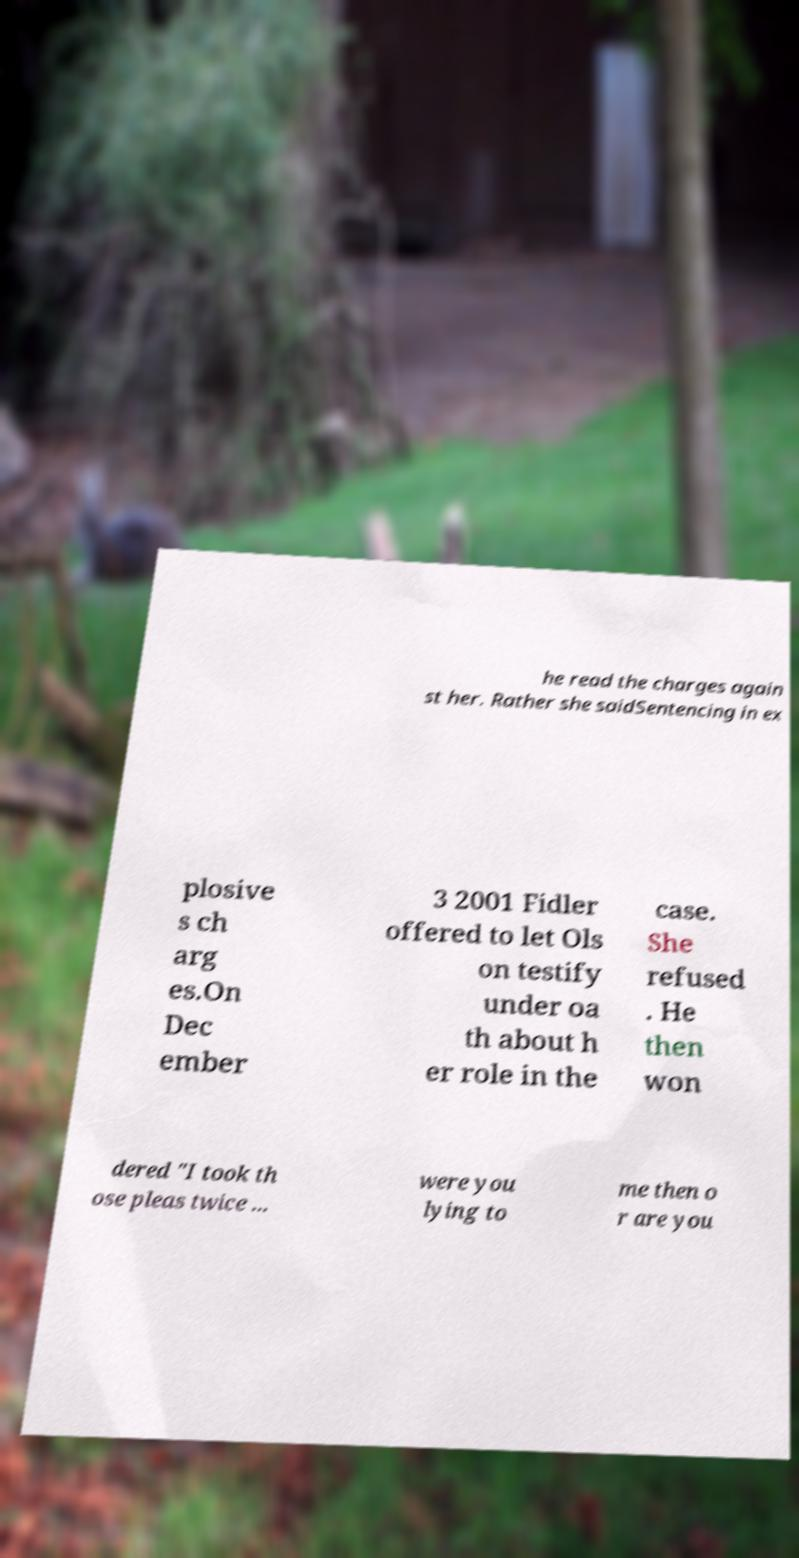For documentation purposes, I need the text within this image transcribed. Could you provide that? he read the charges again st her. Rather she saidSentencing in ex plosive s ch arg es.On Dec ember 3 2001 Fidler offered to let Ols on testify under oa th about h er role in the case. She refused . He then won dered "I took th ose pleas twice ... were you lying to me then o r are you 